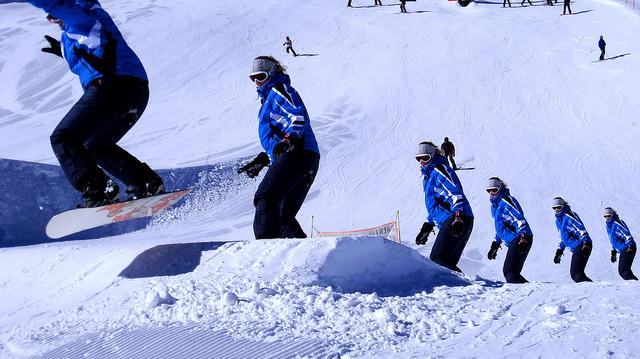What technique was used to manipulate this photo?

Choices:
A) blending
B) cloning
C) time lapse
D) superimposition time lapse 